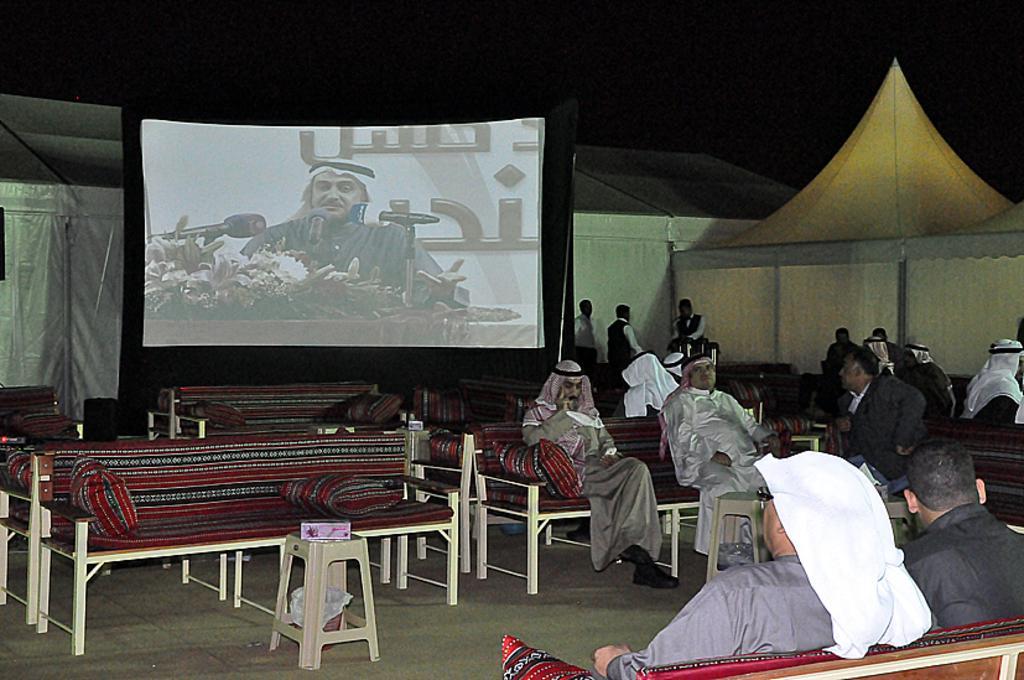Can you describe this image briefly? In this picture we can see some persons sitting on the chairs. This is the floor and there is a screen. On the screen there is a man. These are the flowers. Here we can see some persons are standing on the floor. 